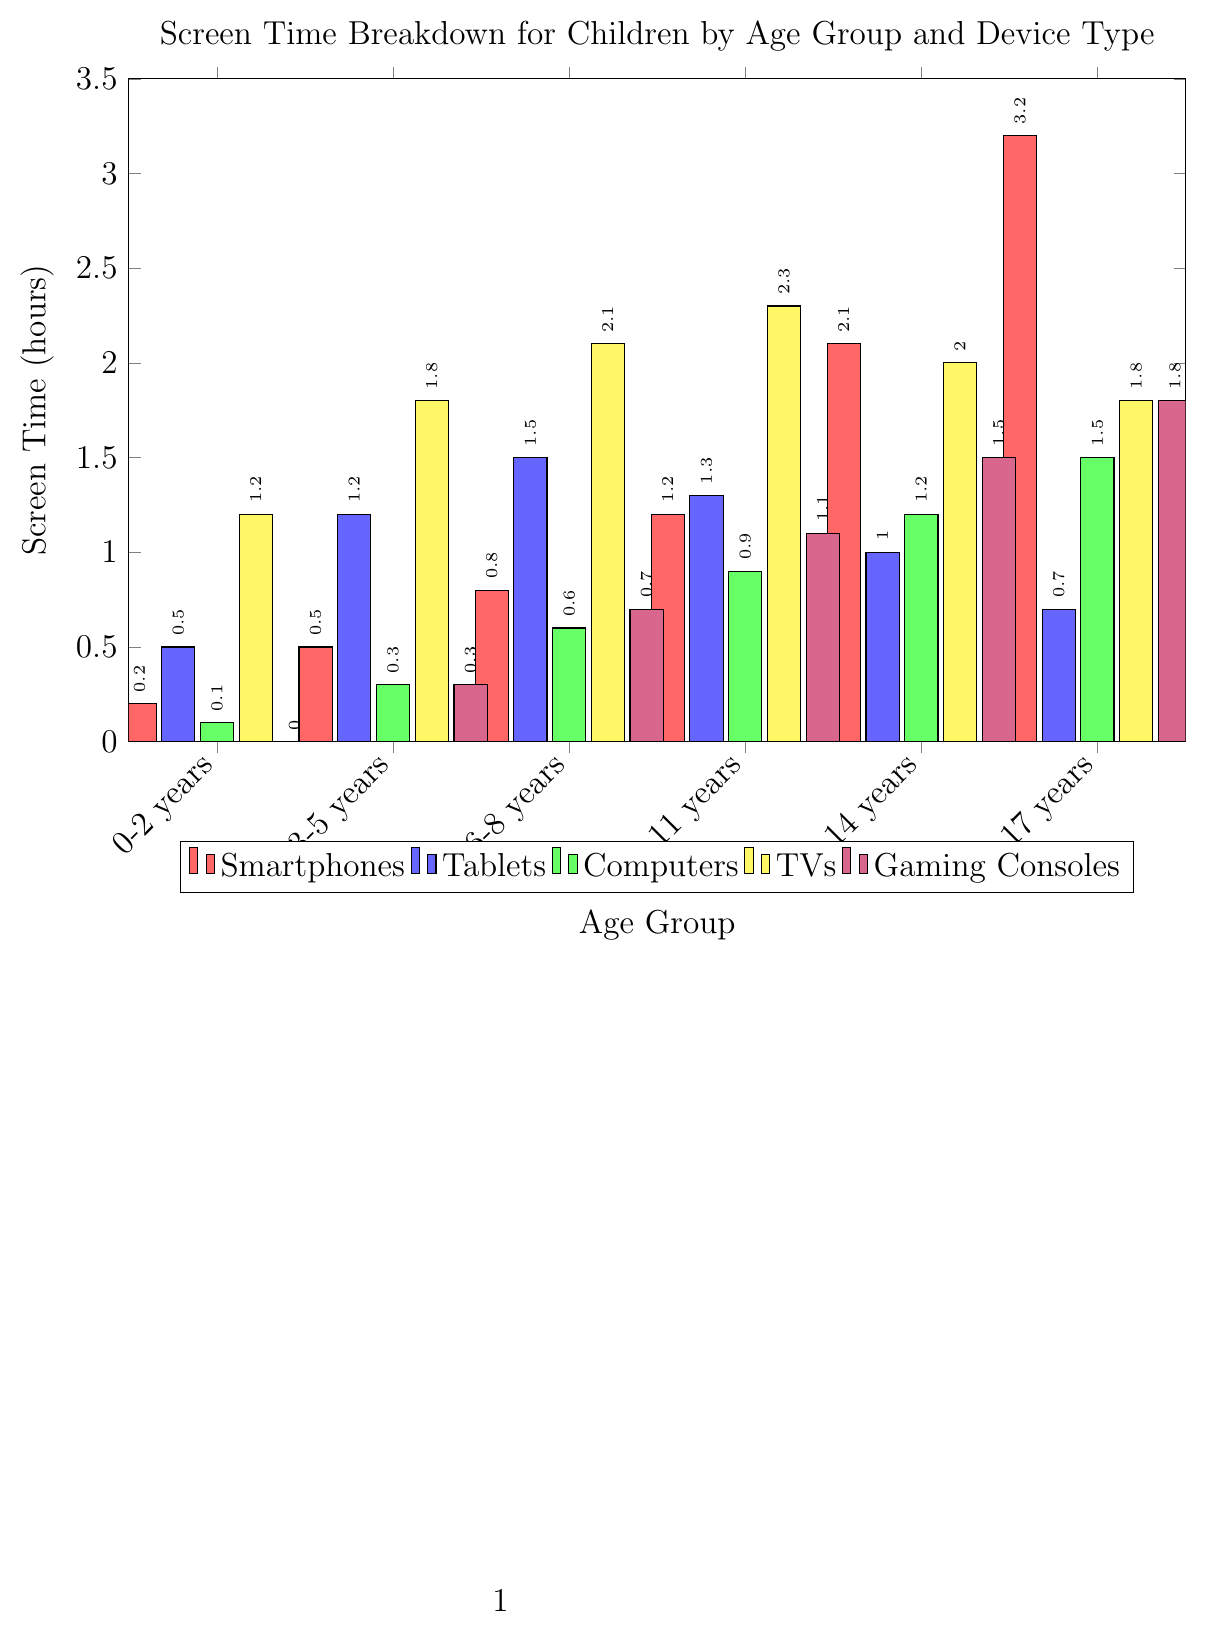What is the total screen time for children aged 3-5 years across all device types? To find the total screen time for children aged 3-5 years, we need to sum the screen times for Smartphones, Tablets, Computers, TVs, and Gaming Consoles: 0.5 + 1.2 + 0.3 + 1.8 + 0.3 = 4.1 hours.
Answer: 4.1 hours Which age group spends the most time on Smartphones? By comparing the heights of the red bars in each age group, we find that the 15-17 years age group has the highest value at 3.2 hours.
Answer: 15-17 years What is the average screen time on Tablets for children aged 0-8 years? We need to find the average of the Tablet screen times for the age groups 0-2 years, 3-5 years, and 6-8 years: (0.5 + 1.2 + 1.5) / 3 = 1.07 hours.
Answer: 1.07 hours How much more screen time do children aged 9-11 years spend on TVs compared to children aged 0-2 years? The TV screen time for children aged 9-11 years is 2.3 hours, and for children aged 0-2 years, it is 1.2 hours. The difference is 2.3 - 1.2 = 1.1 hours.
Answer: 1.1 hours Which device type has the least screen time for children aged 0-2 years? By comparing all the bars for the 0-2 years age group, the purple bar (Gaming Consoles) is the smallest, with a value of 0 hours.
Answer: Gaming Consoles How does the screen time for Gaming Consoles change from the 6-8 years age group to the 12-14 years age group? The Gaming Consoles screen time for the 6-8 years age group is 0.7 hours, and for the 12-14 years age group, it is 1.5 hours. The increase is 1.5 - 0.7 = 0.8 hours.
Answer: Increases by 0.8 hours What is the total screen time for children aged 12-14 years across Smartphones and Computers? We need to sum the screen times for Smartphones and Computers for the 12-14 years age group: 2.1 + 1.2 = 3.3 hours.
Answer: 3.3 hours Which age group watches the most TV? By comparing the heights of the yellow bars, the 9-11 years age group has the highest value at 2.3 hours.
Answer: 9-11 years 